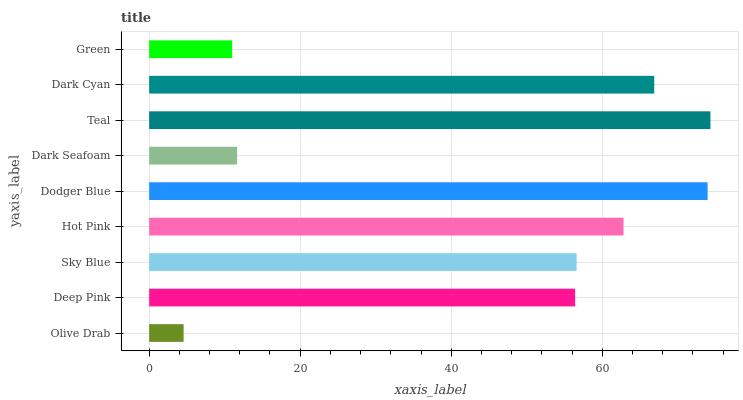Is Olive Drab the minimum?
Answer yes or no. Yes. Is Teal the maximum?
Answer yes or no. Yes. Is Deep Pink the minimum?
Answer yes or no. No. Is Deep Pink the maximum?
Answer yes or no. No. Is Deep Pink greater than Olive Drab?
Answer yes or no. Yes. Is Olive Drab less than Deep Pink?
Answer yes or no. Yes. Is Olive Drab greater than Deep Pink?
Answer yes or no. No. Is Deep Pink less than Olive Drab?
Answer yes or no. No. Is Sky Blue the high median?
Answer yes or no. Yes. Is Sky Blue the low median?
Answer yes or no. Yes. Is Dodger Blue the high median?
Answer yes or no. No. Is Dodger Blue the low median?
Answer yes or no. No. 